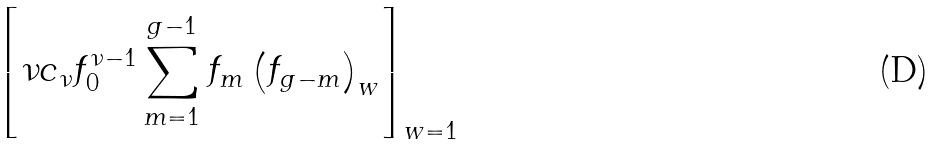Convert formula to latex. <formula><loc_0><loc_0><loc_500><loc_500>\left [ \nu c _ { \nu } f _ { 0 } ^ { \nu - 1 } \sum _ { m = 1 } ^ { g - 1 } f _ { m } \left ( f _ { g - m } \right ) _ { w } \right ] _ { w = 1 }</formula> 